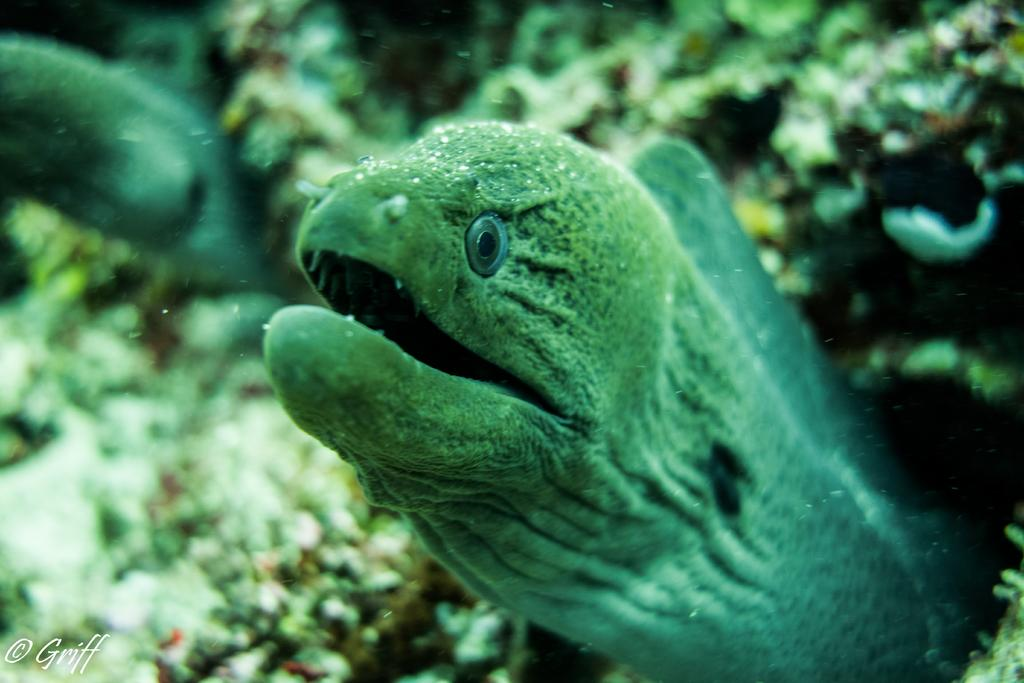What type of animals can be seen in the image? There are fishes in the water. What other elements can be seen in the water? There are submarine plants visible. Can you describe the environment in which the image was taken? The image may have been taken in the ocean. What type of dress can be seen hanging on the sidewalk in the image? There is no dress or sidewalk present in the image; it features fishes and submarine plants in the water. 